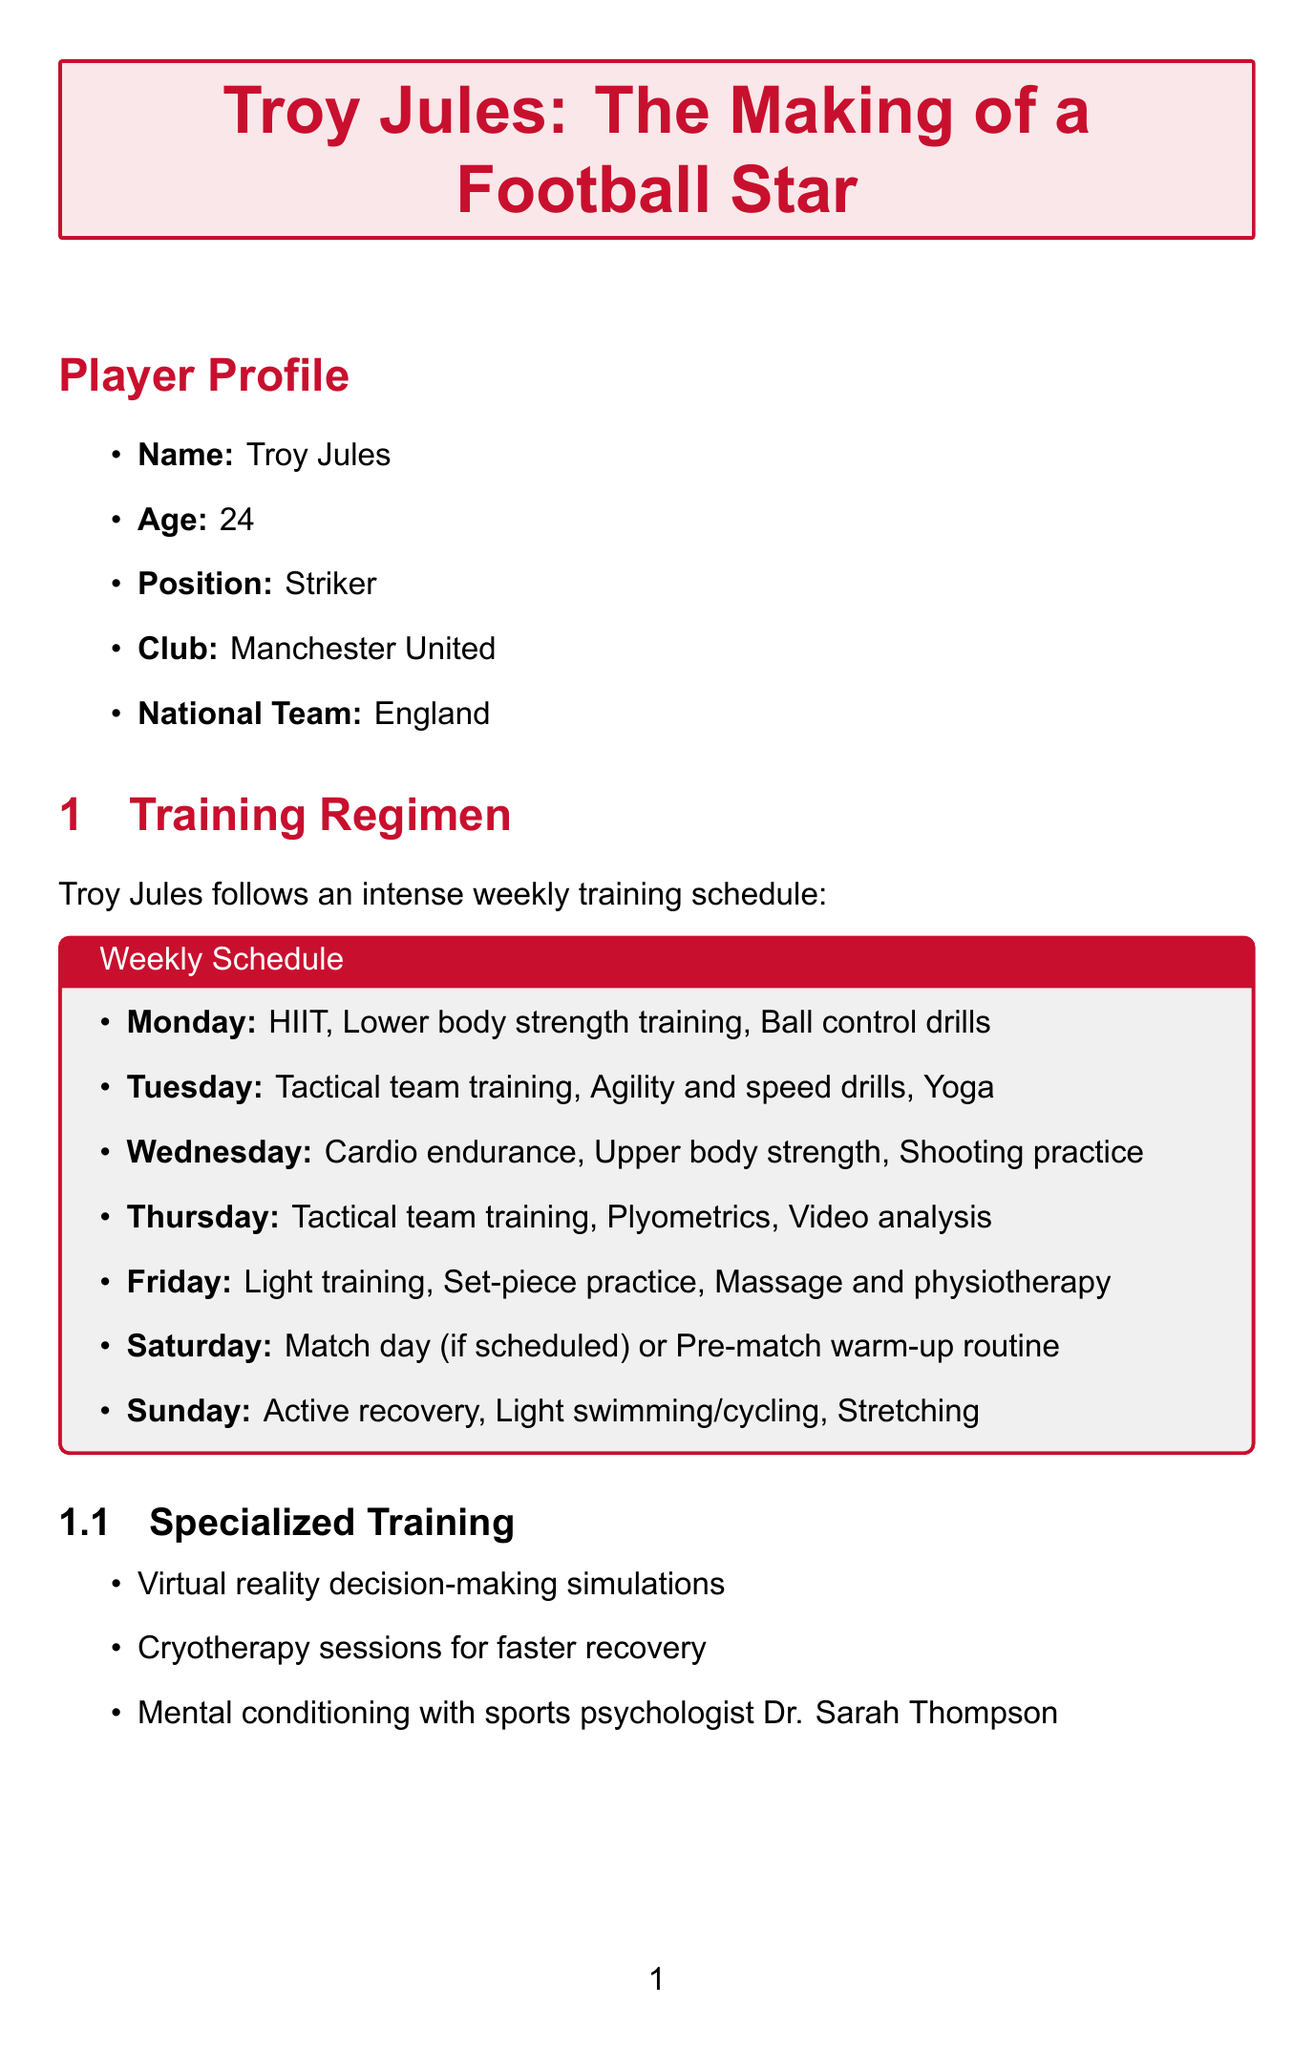What is Troy Jules' age? Troy Jules is 24 years old as stated in the player profile.
Answer: 24 What are the daily protein requirements for Troy's diet? The diet plan specifies Troy's protein intake as 2.2 grams per kg of body weight.
Answer: 2.2g per kg Which day includes yoga recovery sessions? The training regimen indicates that yoga recovery sessions are scheduled for Tuesday.
Answer: Tuesday Who is Troy's nutritionist? The document lists Emma Stevenson as Troy's nutritionist.
Answer: Emma Stevenson What specialized training does Troy participate in for decision-making? The report mentions virtual reality decision-making simulations as part of Troy's specialized training.
Answer: Virtual reality decision-making simulations How many meals are included in Troy's daily meal plan? The meal plan outlines six distinct meals throughout the day.
Answer: Six What is the primary focus of Troy's training according to the fitness coach? Richard Hawkins notes the program focuses on explosive power and agility to enhance Troy's performance.
Answer: Explosive power and agility What is the club that Troy Jules plays for? The player profile clearly states that Troy plays for Manchester United.
Answer: Manchester United What type of recovery activity is suggested for Sundays? The training regimen suggests active recovery, including light swimming or cycling, for Sundays.
Answer: Active recovery 